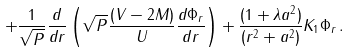Convert formula to latex. <formula><loc_0><loc_0><loc_500><loc_500>+ \frac { 1 } { \sqrt { P } } \frac { d } { d r } \left ( \sqrt { P } \frac { ( V - 2 M ) } { U } \frac { d \Phi _ { r } } { d r } \right ) + \frac { ( 1 + \lambda a ^ { 2 } ) } { ( r ^ { 2 } + a ^ { 2 } ) } K _ { 1 } \Phi _ { r } \, .</formula> 